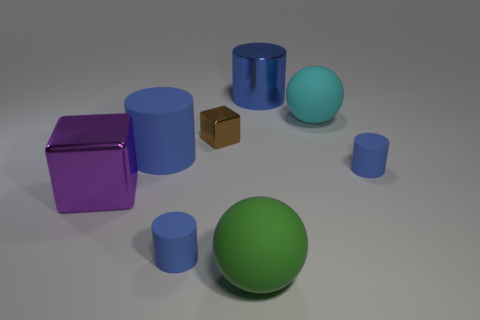There is another big cylinder that is the same color as the big shiny cylinder; what material is it?
Give a very brief answer. Rubber. There is a purple object that is the same shape as the tiny brown thing; what material is it?
Offer a terse response. Metal. Is the number of big red shiny balls greater than the number of metal blocks?
Your response must be concise. No. Is the color of the tiny cube the same as the large shiny cube that is left of the big green thing?
Offer a very short reply. No. What color is the shiny object that is right of the big purple metallic object and in front of the large blue metal thing?
Offer a terse response. Brown. How many other objects are there of the same material as the brown block?
Give a very brief answer. 2. Is the number of rubber cylinders less than the number of blue metallic things?
Offer a very short reply. No. Are the small block and the large purple cube that is in front of the large blue rubber object made of the same material?
Make the answer very short. Yes. What shape is the large blue object that is in front of the big cyan rubber ball?
Your answer should be very brief. Cylinder. Is there anything else that is the same color as the metallic cylinder?
Make the answer very short. Yes. 